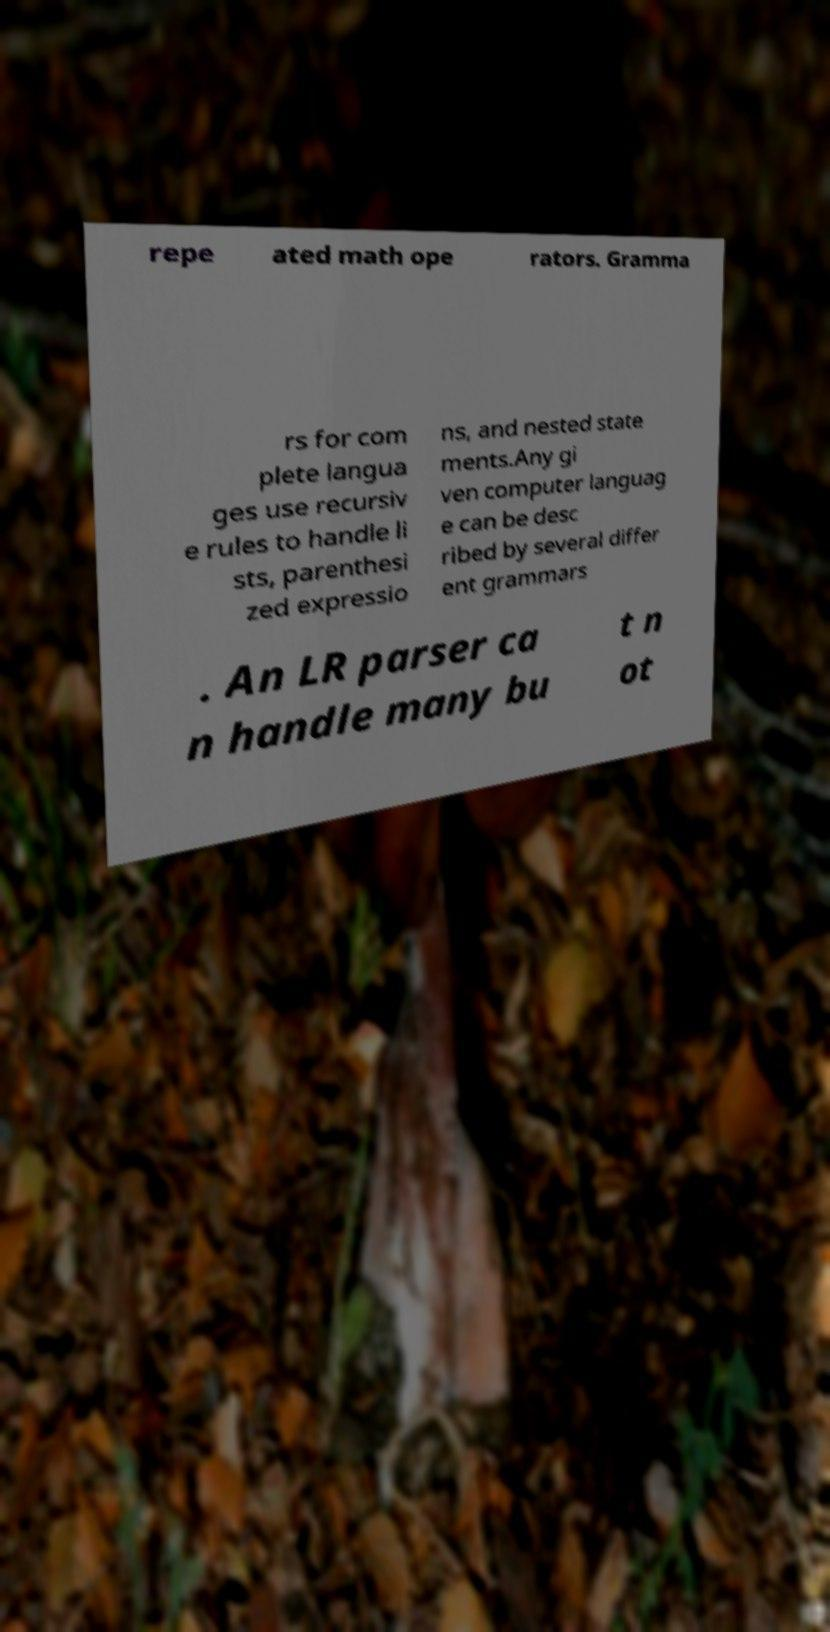Can you accurately transcribe the text from the provided image for me? repe ated math ope rators. Gramma rs for com plete langua ges use recursiv e rules to handle li sts, parenthesi zed expressio ns, and nested state ments.Any gi ven computer languag e can be desc ribed by several differ ent grammars . An LR parser ca n handle many bu t n ot 